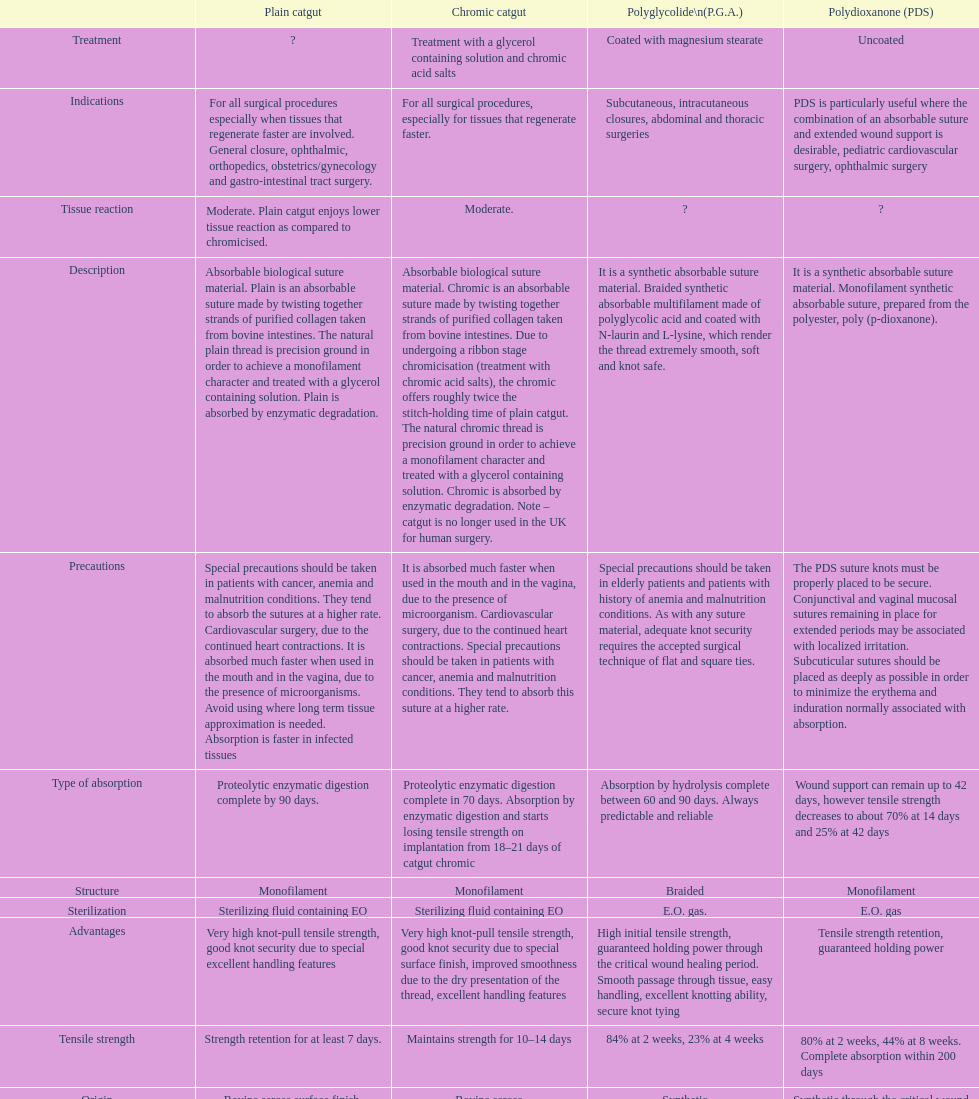Plain catgut and chromic catgut both have what type of structure? Monofilament. 